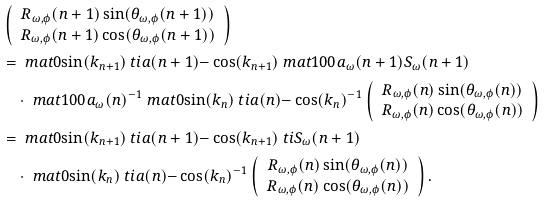Convert formula to latex. <formula><loc_0><loc_0><loc_500><loc_500>& \left ( \begin{array} { c } R _ { \omega , \phi } ( n + 1 ) \sin ( \theta _ { \omega , \phi } ( n + 1 ) ) \\ R _ { \omega , \phi } ( n + 1 ) \cos ( \theta _ { \omega , \phi } ( n + 1 ) ) \end{array} \right ) \\ & = \ m a t { 0 } { \sin ( k _ { n + 1 } ) } { \ t i { a } ( n + 1 ) } { - \cos ( k _ { n + 1 } ) } \ m a t { 1 } { 0 } { 0 } { a _ { \omega } ( n + 1 ) } S _ { \omega } ( n + 1 ) \\ & \quad \cdot \ m a t { 1 } { 0 } { 0 } { a _ { \omega } ( n ) } ^ { - 1 } \ m a t { 0 } { \sin ( k _ { n } ) } { \ t i { a } ( n ) } { - \cos ( k _ { n } ) } ^ { - 1 } \left ( \begin{array} { c } R _ { \omega , \phi } ( n ) \sin ( \theta _ { \omega , \phi } ( n ) ) \\ R _ { \omega , \phi } ( n ) \cos ( \theta _ { \omega , \phi } ( n ) ) \end{array} \right ) \\ & = \ m a t { 0 } { \sin ( k _ { n + 1 } ) } { \ t i { a } ( n + 1 ) } { - \cos ( k _ { n + 1 } ) } \ t i { S } _ { \omega } ( n + 1 ) \\ & \quad \cdot \ m a t { 0 } { \sin ( k _ { n } ) } { \ t i { a } ( n ) } { - \cos ( k _ { n } ) } ^ { - 1 } \left ( \begin{array} { c } R _ { \omega , \phi } ( n ) \sin ( \theta _ { \omega , \phi } ( n ) ) \\ R _ { \omega , \phi } ( n ) \cos ( \theta _ { \omega , \phi } ( n ) ) \end{array} \right ) . \\</formula> 